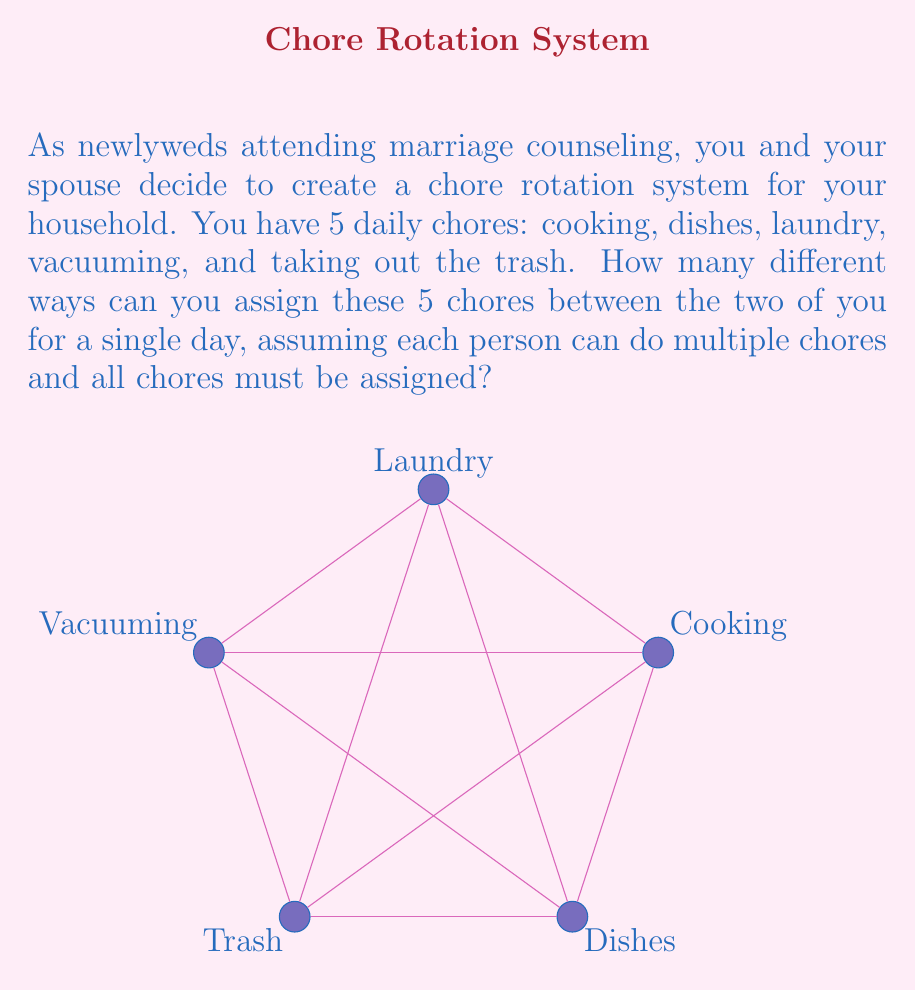Teach me how to tackle this problem. Let's approach this step-by-step:

1) First, we need to understand what we're calculating. This is a problem of permutations in a symmetric group $S_2$, where each chore can be assigned to either person.

2) For each chore, we have 2 choices (you or your spouse). There are 5 chores in total.

3) This scenario can be represented mathematically as:

   $$ 2^5 $$

   This is because for each of the 5 chores, we have 2 choices, and we multiply these together.

4) Let's break it down:
   - Cooking: 2 choices
   - Dishes: 2 choices
   - Laundry: 2 choices
   - Vacuuming: 2 choices
   - Trash: 2 choices

   $2 \times 2 \times 2 \times 2 \times 2 = 2^5$

5) Now, let's calculate $2^5$:

   $2^5 = 2 \times 2 \times 2 \times 2 \times 2 = 32$

Therefore, there are 32 different ways to assign the 5 chores between the two of you.

This exercise in chore assignment flexibility can be a valuable tool in your marriage counseling, promoting fairness and adaptability in your household responsibilities.
Answer: $32$ 